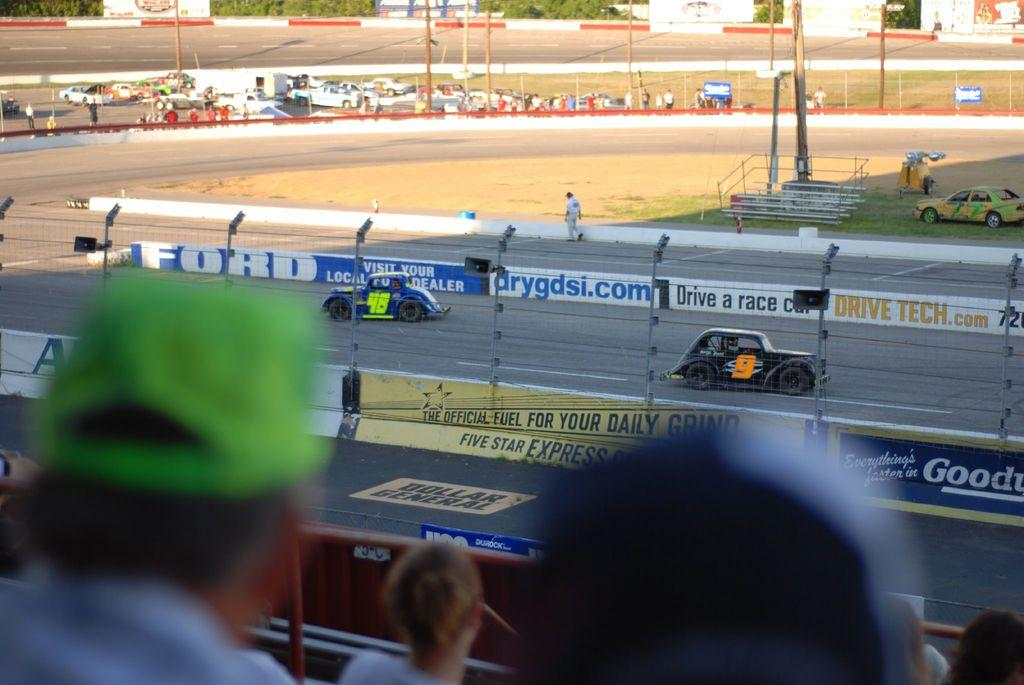What is the main subject in the center of the image? There are vehicles on the road in the center of the image. What can be seen at the bottom of the image? At the bottom of the image, there are lights, persons, and fencing. What is visible in the background of the image? In the background, there is a car, poles, vehicles, a road, and trees. How does the person at the bottom of the image say good-bye to the vehicles? There is no indication in the image that a person is saying good-bye to the vehicles. --- Facts: 1. There is a person holding a book in the image. 2. The person is sitting on a chair. 3. There is a table in the image. 4. The table has a lamp on it. 5. There is a window in the background. 6. The window has curtains. Absurd Topics: dance, ocean, parrot Conversation: What is the person in the image holding? The person in the image is holding a book. What is the person sitting on? The person is sitting on a chair. What is on the table in the image? The table has a lamp on it. What can be seen in the background of the image? There is a window in the background, and the window has curtains. Reasoning: Let's think step by step in order to produce the conversation. We start by identifying the main subject in the image, which is the person holding a book. Then, we expand the conversation to include other elements visible in the image, such as the chair, table, lamp, window, and curtains. Each question is designed to elicit a specific detail about the image that is known from the provided facts. Absurd Question/Answer: Can you see the parrot dancing on the ocean in the image? There is no parrot or ocean present in the image. 